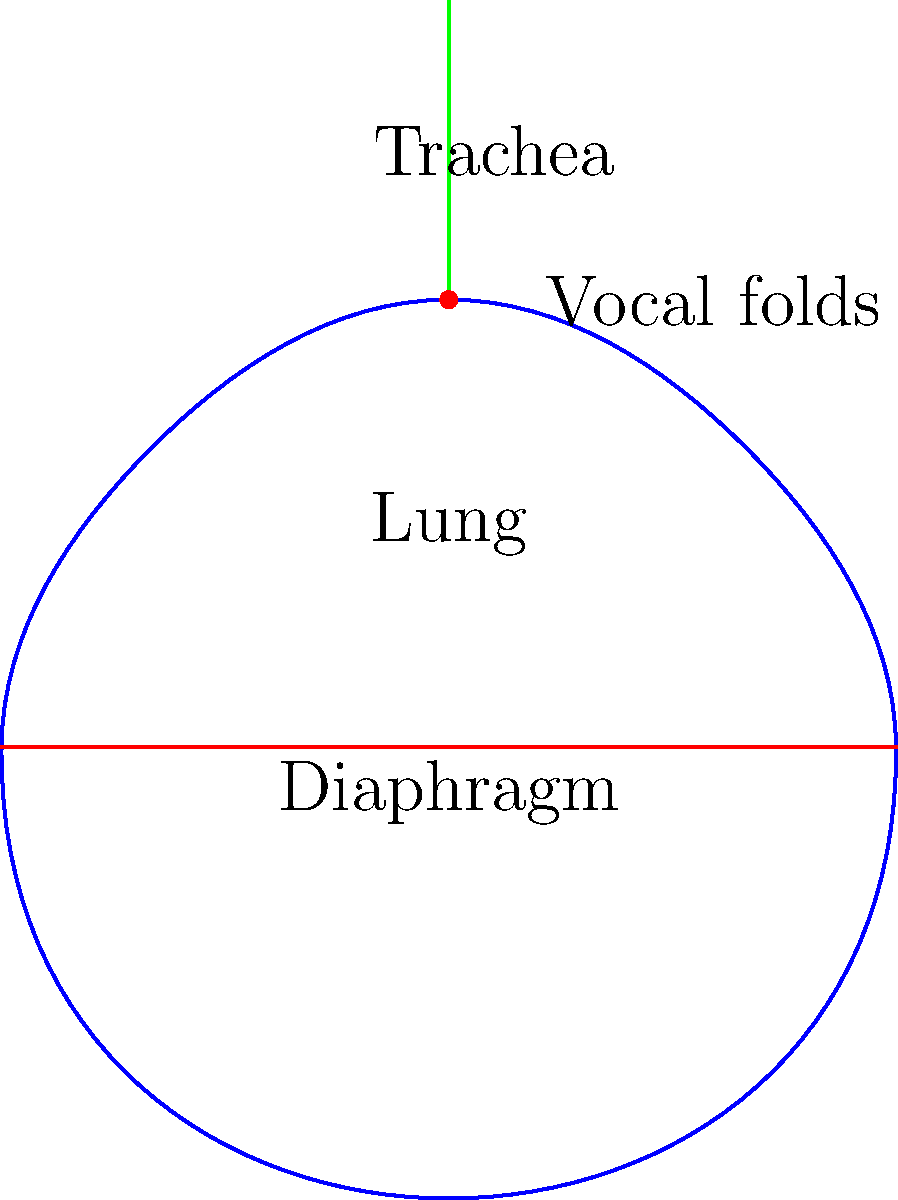During a sustained note, which biomechanical process is primarily responsible for maintaining consistent air pressure through the vocal folds, as illustrated in the lung diagram? To understand the biomechanics of breath control for sustained notes, let's break down the process:

1. Initial inhalation: The diaphragm contracts and moves downward, increasing lung volume.

2. Controlled exhalation: As air is expelled, the following occurs:
   a) The diaphragm gradually relaxes and moves upward.
   b) The intercostal muscles contract to maintain rib cage expansion.
   c) The abdominal muscles contract to provide additional pressure.

3. Pressure regulation: The key to maintaining consistent air pressure is the balanced contraction of the abdominal muscles and the controlled relaxation of the diaphragm.

4. Laryngeal adjustment: The vocal folds adjust to maintain a consistent vibration frequency.

5. Airflow control: The space between the vocal folds (glottis) is precisely regulated to maintain steady airflow.

The primary biomechanical process responsible for maintaining consistent air pressure is the coordinated action of the abdominal muscles. This process, known as appoggio technique in singing, involves the controlled contraction of the abdominal muscles to provide steady, consistent air pressure through the vocal folds.
Answer: Controlled abdominal muscle contraction (appoggio technique) 